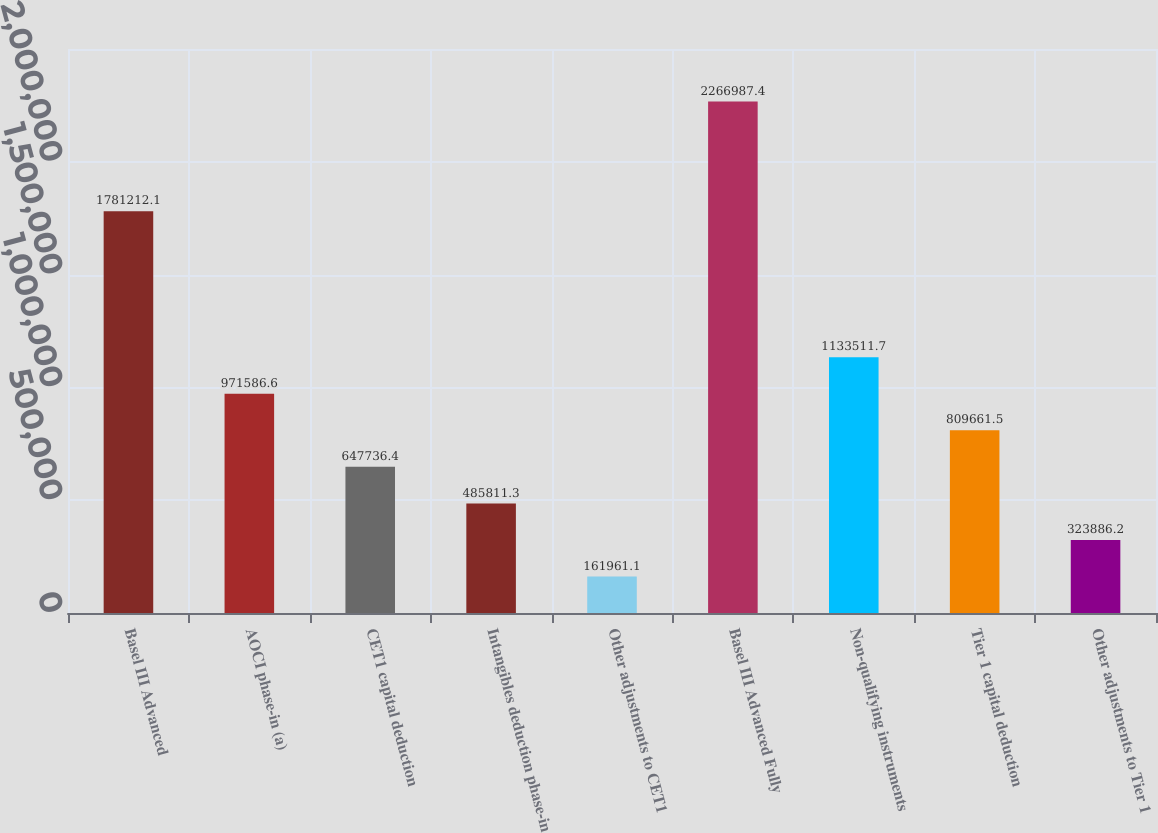<chart> <loc_0><loc_0><loc_500><loc_500><bar_chart><fcel>Basel III Advanced<fcel>AOCI phase-in (a)<fcel>CET1 capital deduction<fcel>Intangibles deduction phase-in<fcel>Other adjustments to CET1<fcel>Basel III Advanced Fully<fcel>Non-qualifying instruments<fcel>Tier 1 capital deduction<fcel>Other adjustments to Tier 1<nl><fcel>1.78121e+06<fcel>971587<fcel>647736<fcel>485811<fcel>161961<fcel>2.26699e+06<fcel>1.13351e+06<fcel>809662<fcel>323886<nl></chart> 